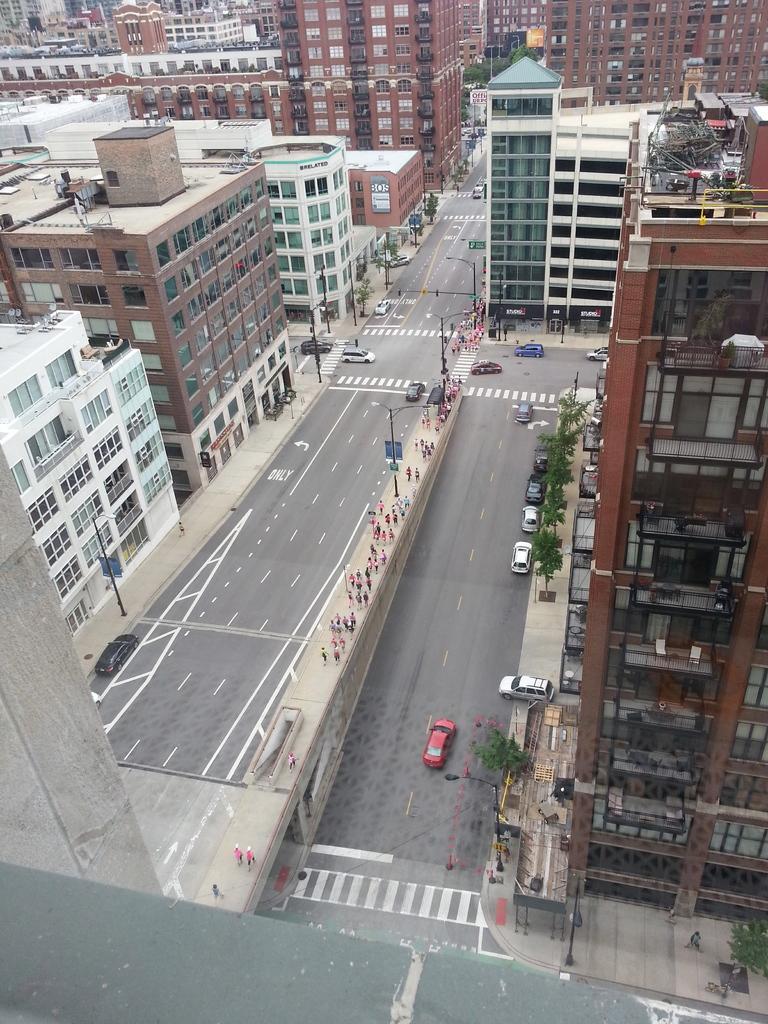Can you describe this image briefly? This image is taken from the top view. In this image we can see many buildings. We can also see the trees, vehicles, poles with lights and also sign boards. We can also see the road and there are people walking on the path. 